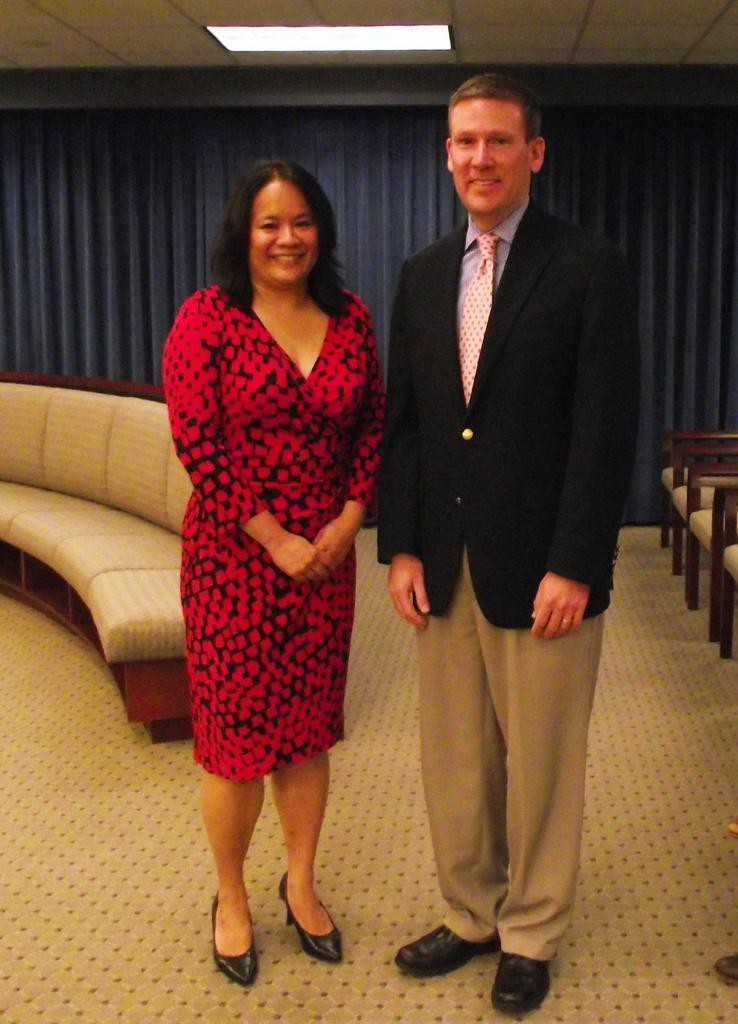Who are the people in the image? There is a man and a woman in the image. What is the setting of the image? They are standing on a floor. What furniture can be seen in the background of the image? There is a sofa and chairs in the background of the image. What type of curtain is present in the background of the image? There is a black curtain in the background of the image. What is visible above the people in the image? There is a ceiling visible in the image, and a light is on the ceiling. What type of shoes can be seen in the image? There is no mention of shoes in the image, so it cannot be determined what type of shoes might be present. 